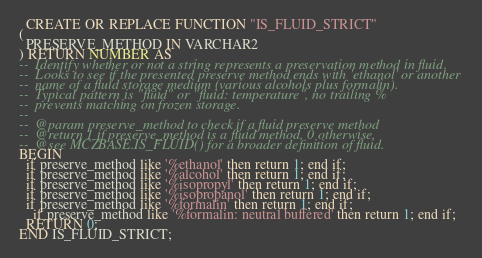<code> <loc_0><loc_0><loc_500><loc_500><_SQL_>
  CREATE OR REPLACE FUNCTION "IS_FLUID_STRICT" 
(
  PRESERVE_METHOD IN VARCHAR2  
) RETURN NUMBER AS 
--  Identify whether or not a string represents a preservation method in fluid.
--  Looks to see if the presented preserve method ends with 'ethanol' or another 
--  name of a fluid storage medium (various alcohols plus formalin).
--  Typical pattern is "fluid" or "fluid: temperature", no trailing %
--  prevents matching on frozen storage.
--
--  @param preserve_method to check if a fluid preserve method
--  @return 1 if preserve_method is a fluid method, 0 otherwise.
--  @see MCZBASE.IS_FLUID() for a broader definition of fluid.
BEGIN
  if preserve_method like '%ethanol' then return 1; end if;
  if preserve_method like '%alcohol' then return 1; end if;
  if preserve_method like '%isopropyl' then return 1; end if;
  if preserve_method like '%isopropanol' then return 1; end if;
  if preserve_method like '%formalin' then return 1; end if;
    if preserve_method like '%formalin: neutral buffered' then return 1; end if; 
  RETURN 0;
END IS_FLUID_STRICT;</code> 